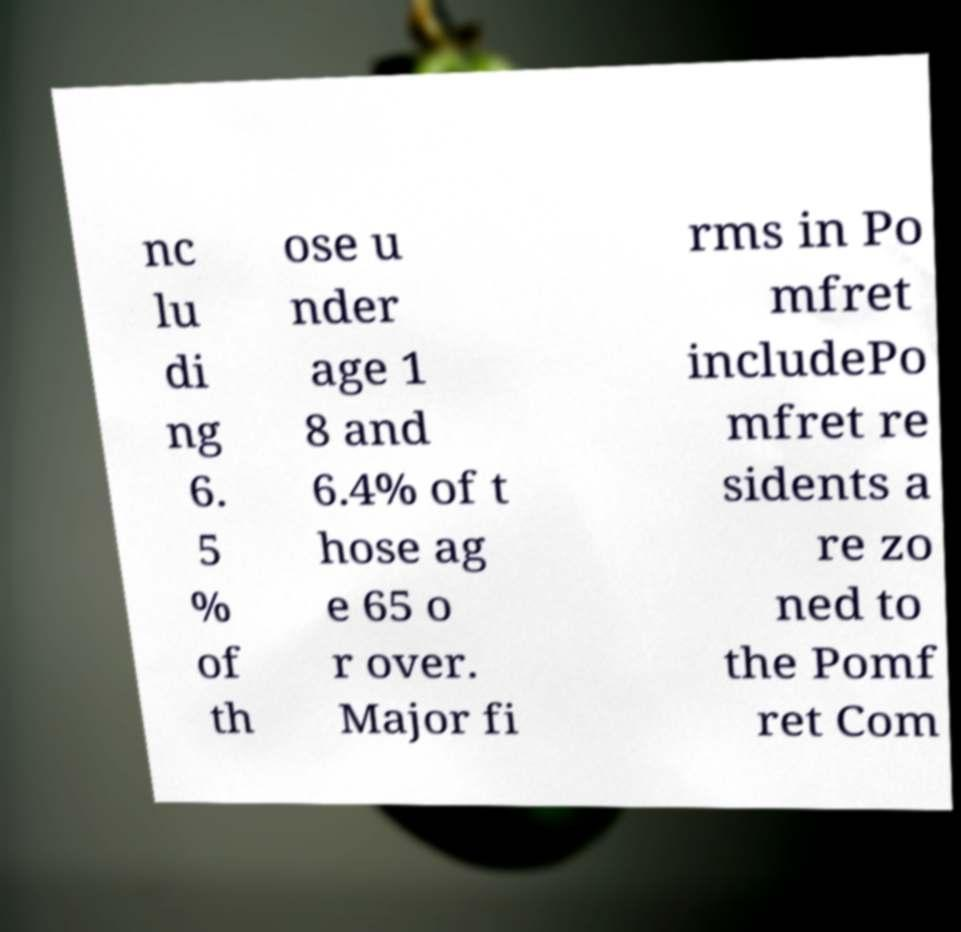There's text embedded in this image that I need extracted. Can you transcribe it verbatim? nc lu di ng 6. 5 % of th ose u nder age 1 8 and 6.4% of t hose ag e 65 o r over. Major fi rms in Po mfret includePo mfret re sidents a re zo ned to the Pomf ret Com 